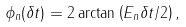<formula> <loc_0><loc_0><loc_500><loc_500>\phi _ { n } ( \delta t ) = 2 \arctan \left ( E _ { n } \delta t / 2 \right ) ,</formula> 